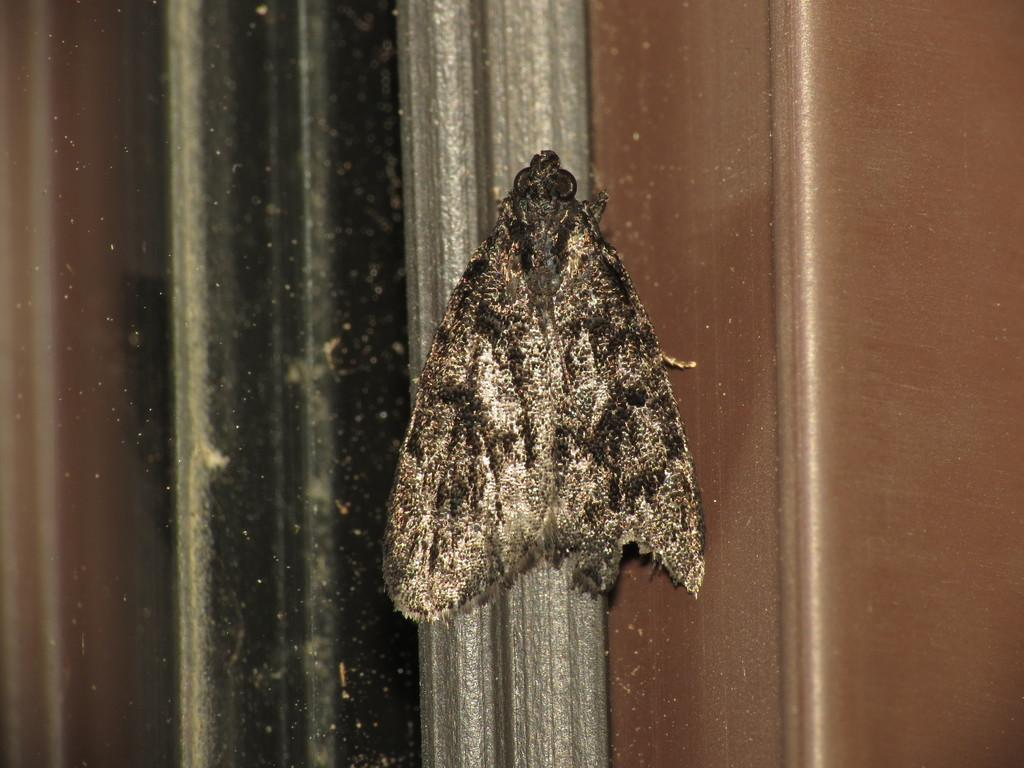What type of creature is present in the image? There is an insect in the image. Can you describe the color of the insect? The insect is black and cream in color. What is the insect resting on or near in the image? The insect is on a grey, brown, and black colored object. What type of honey is being used by the insect in the image? There is no honey present in the image, and the insect is not using any honey. 